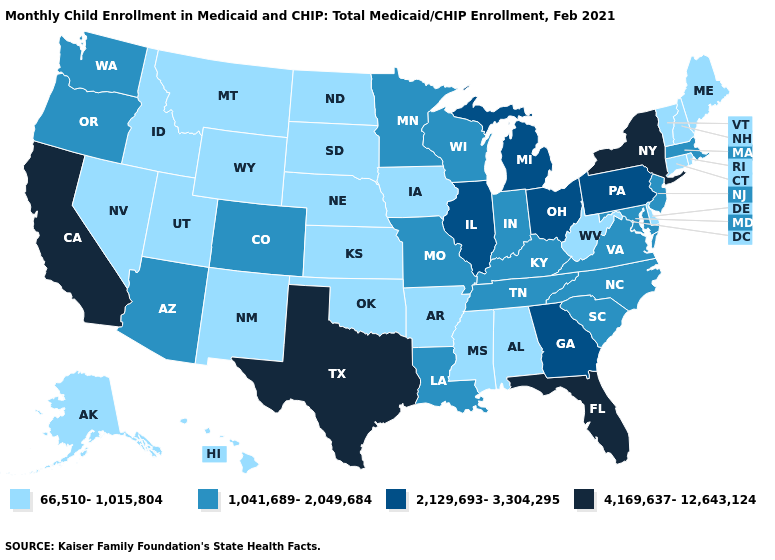Is the legend a continuous bar?
Quick response, please. No. Which states hav the highest value in the MidWest?
Quick response, please. Illinois, Michigan, Ohio. Which states have the lowest value in the USA?
Quick response, please. Alabama, Alaska, Arkansas, Connecticut, Delaware, Hawaii, Idaho, Iowa, Kansas, Maine, Mississippi, Montana, Nebraska, Nevada, New Hampshire, New Mexico, North Dakota, Oklahoma, Rhode Island, South Dakota, Utah, Vermont, West Virginia, Wyoming. Does New York have the same value as West Virginia?
Answer briefly. No. Is the legend a continuous bar?
Give a very brief answer. No. Among the states that border California , does Nevada have the lowest value?
Answer briefly. Yes. Does Indiana have the lowest value in the USA?
Answer briefly. No. What is the value of Arkansas?
Quick response, please. 66,510-1,015,804. Among the states that border California , does Nevada have the highest value?
Write a very short answer. No. Name the states that have a value in the range 66,510-1,015,804?
Answer briefly. Alabama, Alaska, Arkansas, Connecticut, Delaware, Hawaii, Idaho, Iowa, Kansas, Maine, Mississippi, Montana, Nebraska, Nevada, New Hampshire, New Mexico, North Dakota, Oklahoma, Rhode Island, South Dakota, Utah, Vermont, West Virginia, Wyoming. What is the lowest value in the West?
Short answer required. 66,510-1,015,804. Among the states that border Arizona , which have the highest value?
Keep it brief. California. What is the value of Illinois?
Keep it brief. 2,129,693-3,304,295. Does Alabama have a higher value than Illinois?
Write a very short answer. No. Does the first symbol in the legend represent the smallest category?
Concise answer only. Yes. 